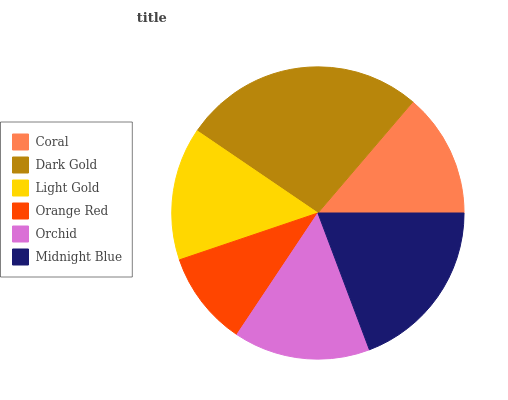Is Orange Red the minimum?
Answer yes or no. Yes. Is Dark Gold the maximum?
Answer yes or no. Yes. Is Light Gold the minimum?
Answer yes or no. No. Is Light Gold the maximum?
Answer yes or no. No. Is Dark Gold greater than Light Gold?
Answer yes or no. Yes. Is Light Gold less than Dark Gold?
Answer yes or no. Yes. Is Light Gold greater than Dark Gold?
Answer yes or no. No. Is Dark Gold less than Light Gold?
Answer yes or no. No. Is Orchid the high median?
Answer yes or no. Yes. Is Light Gold the low median?
Answer yes or no. Yes. Is Orange Red the high median?
Answer yes or no. No. Is Orchid the low median?
Answer yes or no. No. 